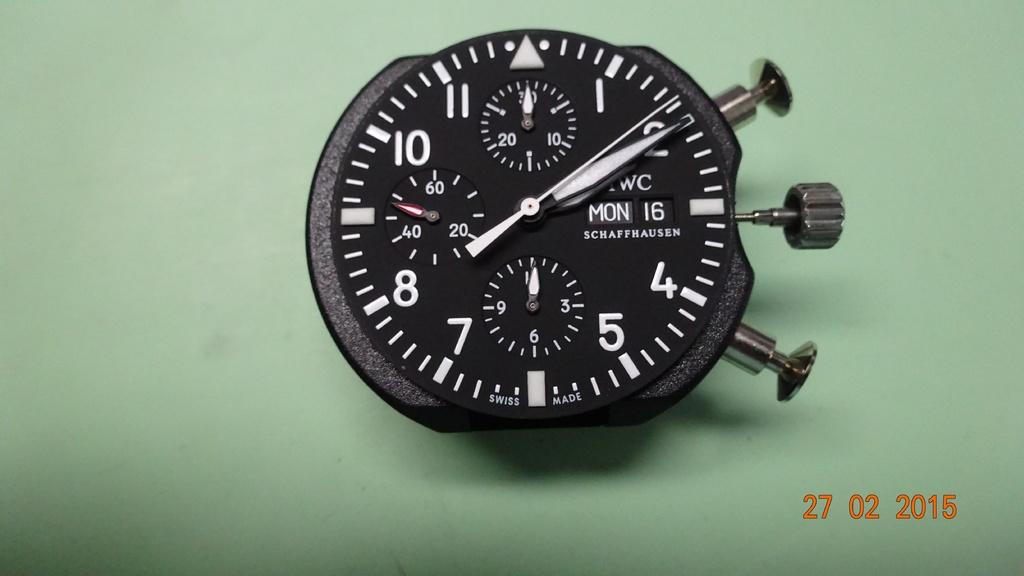<image>
Present a compact description of the photo's key features. A Schaffhausen stop watch on a green background. 